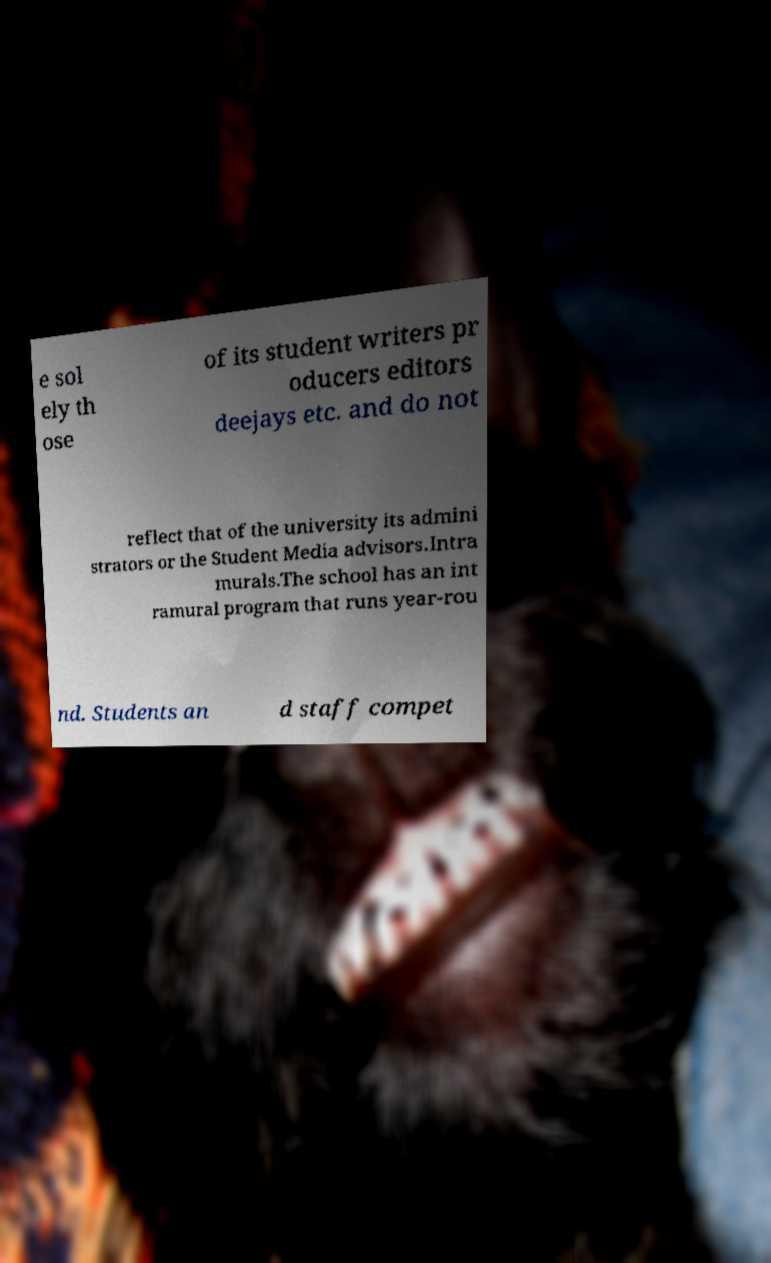I need the written content from this picture converted into text. Can you do that? e sol ely th ose of its student writers pr oducers editors deejays etc. and do not reflect that of the university its admini strators or the Student Media advisors.Intra murals.The school has an int ramural program that runs year-rou nd. Students an d staff compet 